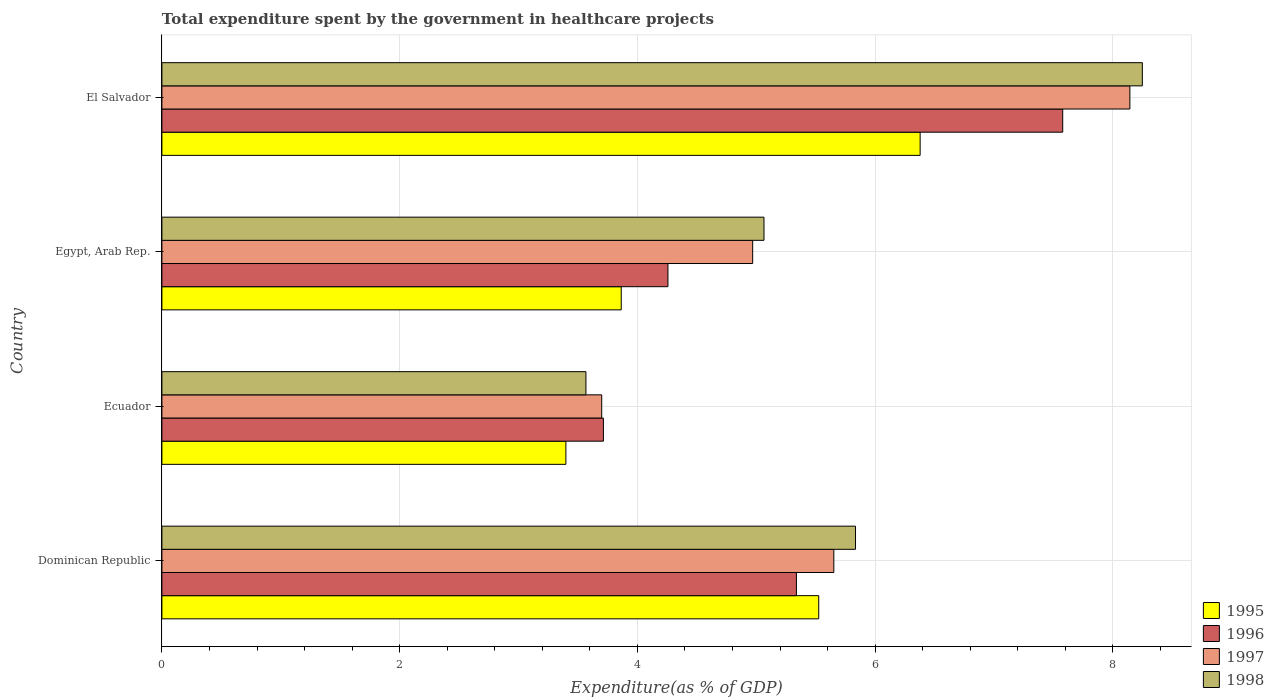How many different coloured bars are there?
Provide a succinct answer. 4. How many groups of bars are there?
Give a very brief answer. 4. Are the number of bars per tick equal to the number of legend labels?
Your answer should be compact. Yes. Are the number of bars on each tick of the Y-axis equal?
Give a very brief answer. Yes. How many bars are there on the 4th tick from the bottom?
Provide a succinct answer. 4. What is the label of the 3rd group of bars from the top?
Offer a very short reply. Ecuador. What is the total expenditure spent by the government in healthcare projects in 1996 in Egypt, Arab Rep.?
Offer a terse response. 4.26. Across all countries, what is the maximum total expenditure spent by the government in healthcare projects in 1995?
Your response must be concise. 6.38. Across all countries, what is the minimum total expenditure spent by the government in healthcare projects in 1997?
Ensure brevity in your answer.  3.7. In which country was the total expenditure spent by the government in healthcare projects in 1996 maximum?
Give a very brief answer. El Salvador. In which country was the total expenditure spent by the government in healthcare projects in 1997 minimum?
Offer a very short reply. Ecuador. What is the total total expenditure spent by the government in healthcare projects in 1997 in the graph?
Your answer should be very brief. 22.47. What is the difference between the total expenditure spent by the government in healthcare projects in 1995 in Dominican Republic and that in Egypt, Arab Rep.?
Provide a short and direct response. 1.66. What is the difference between the total expenditure spent by the government in healthcare projects in 1998 in Egypt, Arab Rep. and the total expenditure spent by the government in healthcare projects in 1996 in Ecuador?
Keep it short and to the point. 1.35. What is the average total expenditure spent by the government in healthcare projects in 1996 per country?
Ensure brevity in your answer.  5.22. What is the difference between the total expenditure spent by the government in healthcare projects in 1995 and total expenditure spent by the government in healthcare projects in 1996 in Ecuador?
Ensure brevity in your answer.  -0.32. In how many countries, is the total expenditure spent by the government in healthcare projects in 1997 greater than 7.2 %?
Provide a succinct answer. 1. What is the ratio of the total expenditure spent by the government in healthcare projects in 1995 in Egypt, Arab Rep. to that in El Salvador?
Provide a short and direct response. 0.61. Is the total expenditure spent by the government in healthcare projects in 1998 in Ecuador less than that in El Salvador?
Keep it short and to the point. Yes. Is the difference between the total expenditure spent by the government in healthcare projects in 1995 in Dominican Republic and El Salvador greater than the difference between the total expenditure spent by the government in healthcare projects in 1996 in Dominican Republic and El Salvador?
Make the answer very short. Yes. What is the difference between the highest and the second highest total expenditure spent by the government in healthcare projects in 1998?
Give a very brief answer. 2.41. What is the difference between the highest and the lowest total expenditure spent by the government in healthcare projects in 1996?
Your answer should be compact. 3.86. In how many countries, is the total expenditure spent by the government in healthcare projects in 1995 greater than the average total expenditure spent by the government in healthcare projects in 1995 taken over all countries?
Keep it short and to the point. 2. Is the sum of the total expenditure spent by the government in healthcare projects in 1997 in Egypt, Arab Rep. and El Salvador greater than the maximum total expenditure spent by the government in healthcare projects in 1995 across all countries?
Offer a terse response. Yes. What does the 2nd bar from the top in Egypt, Arab Rep. represents?
Provide a succinct answer. 1997. What does the 2nd bar from the bottom in Egypt, Arab Rep. represents?
Ensure brevity in your answer.  1996. Is it the case that in every country, the sum of the total expenditure spent by the government in healthcare projects in 1997 and total expenditure spent by the government in healthcare projects in 1998 is greater than the total expenditure spent by the government in healthcare projects in 1996?
Offer a terse response. Yes. How many bars are there?
Ensure brevity in your answer.  16. Are all the bars in the graph horizontal?
Ensure brevity in your answer.  Yes. How many countries are there in the graph?
Offer a very short reply. 4. Where does the legend appear in the graph?
Provide a short and direct response. Bottom right. What is the title of the graph?
Make the answer very short. Total expenditure spent by the government in healthcare projects. Does "2000" appear as one of the legend labels in the graph?
Offer a terse response. No. What is the label or title of the X-axis?
Your answer should be compact. Expenditure(as % of GDP). What is the label or title of the Y-axis?
Ensure brevity in your answer.  Country. What is the Expenditure(as % of GDP) in 1995 in Dominican Republic?
Keep it short and to the point. 5.53. What is the Expenditure(as % of GDP) in 1996 in Dominican Republic?
Provide a succinct answer. 5.34. What is the Expenditure(as % of GDP) in 1997 in Dominican Republic?
Make the answer very short. 5.65. What is the Expenditure(as % of GDP) in 1998 in Dominican Republic?
Your answer should be compact. 5.84. What is the Expenditure(as % of GDP) in 1995 in Ecuador?
Offer a terse response. 3.4. What is the Expenditure(as % of GDP) of 1996 in Ecuador?
Give a very brief answer. 3.71. What is the Expenditure(as % of GDP) of 1997 in Ecuador?
Offer a terse response. 3.7. What is the Expenditure(as % of GDP) in 1998 in Ecuador?
Provide a short and direct response. 3.57. What is the Expenditure(as % of GDP) of 1995 in Egypt, Arab Rep.?
Provide a succinct answer. 3.86. What is the Expenditure(as % of GDP) of 1996 in Egypt, Arab Rep.?
Give a very brief answer. 4.26. What is the Expenditure(as % of GDP) of 1997 in Egypt, Arab Rep.?
Ensure brevity in your answer.  4.97. What is the Expenditure(as % of GDP) of 1998 in Egypt, Arab Rep.?
Provide a succinct answer. 5.07. What is the Expenditure(as % of GDP) of 1995 in El Salvador?
Provide a short and direct response. 6.38. What is the Expenditure(as % of GDP) of 1996 in El Salvador?
Provide a succinct answer. 7.58. What is the Expenditure(as % of GDP) of 1997 in El Salvador?
Provide a succinct answer. 8.14. What is the Expenditure(as % of GDP) of 1998 in El Salvador?
Offer a terse response. 8.25. Across all countries, what is the maximum Expenditure(as % of GDP) of 1995?
Provide a succinct answer. 6.38. Across all countries, what is the maximum Expenditure(as % of GDP) of 1996?
Provide a short and direct response. 7.58. Across all countries, what is the maximum Expenditure(as % of GDP) in 1997?
Provide a short and direct response. 8.14. Across all countries, what is the maximum Expenditure(as % of GDP) in 1998?
Your answer should be compact. 8.25. Across all countries, what is the minimum Expenditure(as % of GDP) of 1995?
Keep it short and to the point. 3.4. Across all countries, what is the minimum Expenditure(as % of GDP) in 1996?
Offer a very short reply. 3.71. Across all countries, what is the minimum Expenditure(as % of GDP) of 1997?
Your answer should be compact. 3.7. Across all countries, what is the minimum Expenditure(as % of GDP) of 1998?
Ensure brevity in your answer.  3.57. What is the total Expenditure(as % of GDP) in 1995 in the graph?
Offer a very short reply. 19.17. What is the total Expenditure(as % of GDP) of 1996 in the graph?
Give a very brief answer. 20.89. What is the total Expenditure(as % of GDP) of 1997 in the graph?
Give a very brief answer. 22.47. What is the total Expenditure(as % of GDP) of 1998 in the graph?
Your answer should be compact. 22.72. What is the difference between the Expenditure(as % of GDP) of 1995 in Dominican Republic and that in Ecuador?
Your answer should be very brief. 2.13. What is the difference between the Expenditure(as % of GDP) of 1996 in Dominican Republic and that in Ecuador?
Your response must be concise. 1.62. What is the difference between the Expenditure(as % of GDP) in 1997 in Dominican Republic and that in Ecuador?
Provide a short and direct response. 1.95. What is the difference between the Expenditure(as % of GDP) in 1998 in Dominican Republic and that in Ecuador?
Offer a terse response. 2.27. What is the difference between the Expenditure(as % of GDP) of 1995 in Dominican Republic and that in Egypt, Arab Rep.?
Your answer should be very brief. 1.66. What is the difference between the Expenditure(as % of GDP) in 1996 in Dominican Republic and that in Egypt, Arab Rep.?
Provide a succinct answer. 1.08. What is the difference between the Expenditure(as % of GDP) of 1997 in Dominican Republic and that in Egypt, Arab Rep.?
Your answer should be very brief. 0.68. What is the difference between the Expenditure(as % of GDP) in 1998 in Dominican Republic and that in Egypt, Arab Rep.?
Give a very brief answer. 0.77. What is the difference between the Expenditure(as % of GDP) in 1995 in Dominican Republic and that in El Salvador?
Give a very brief answer. -0.85. What is the difference between the Expenditure(as % of GDP) of 1996 in Dominican Republic and that in El Salvador?
Your answer should be very brief. -2.24. What is the difference between the Expenditure(as % of GDP) in 1997 in Dominican Republic and that in El Salvador?
Make the answer very short. -2.49. What is the difference between the Expenditure(as % of GDP) of 1998 in Dominican Republic and that in El Salvador?
Keep it short and to the point. -2.41. What is the difference between the Expenditure(as % of GDP) of 1995 in Ecuador and that in Egypt, Arab Rep.?
Give a very brief answer. -0.47. What is the difference between the Expenditure(as % of GDP) of 1996 in Ecuador and that in Egypt, Arab Rep.?
Offer a terse response. -0.54. What is the difference between the Expenditure(as % of GDP) of 1997 in Ecuador and that in Egypt, Arab Rep.?
Ensure brevity in your answer.  -1.27. What is the difference between the Expenditure(as % of GDP) of 1998 in Ecuador and that in Egypt, Arab Rep.?
Your response must be concise. -1.5. What is the difference between the Expenditure(as % of GDP) in 1995 in Ecuador and that in El Salvador?
Provide a short and direct response. -2.98. What is the difference between the Expenditure(as % of GDP) of 1996 in Ecuador and that in El Salvador?
Your answer should be compact. -3.86. What is the difference between the Expenditure(as % of GDP) of 1997 in Ecuador and that in El Salvador?
Your answer should be compact. -4.44. What is the difference between the Expenditure(as % of GDP) of 1998 in Ecuador and that in El Salvador?
Keep it short and to the point. -4.68. What is the difference between the Expenditure(as % of GDP) of 1995 in Egypt, Arab Rep. and that in El Salvador?
Keep it short and to the point. -2.51. What is the difference between the Expenditure(as % of GDP) in 1996 in Egypt, Arab Rep. and that in El Salvador?
Ensure brevity in your answer.  -3.32. What is the difference between the Expenditure(as % of GDP) of 1997 in Egypt, Arab Rep. and that in El Salvador?
Provide a succinct answer. -3.17. What is the difference between the Expenditure(as % of GDP) of 1998 in Egypt, Arab Rep. and that in El Salvador?
Keep it short and to the point. -3.18. What is the difference between the Expenditure(as % of GDP) in 1995 in Dominican Republic and the Expenditure(as % of GDP) in 1996 in Ecuador?
Your answer should be very brief. 1.81. What is the difference between the Expenditure(as % of GDP) in 1995 in Dominican Republic and the Expenditure(as % of GDP) in 1997 in Ecuador?
Ensure brevity in your answer.  1.83. What is the difference between the Expenditure(as % of GDP) in 1995 in Dominican Republic and the Expenditure(as % of GDP) in 1998 in Ecuador?
Your answer should be compact. 1.96. What is the difference between the Expenditure(as % of GDP) in 1996 in Dominican Republic and the Expenditure(as % of GDP) in 1997 in Ecuador?
Your answer should be very brief. 1.64. What is the difference between the Expenditure(as % of GDP) of 1996 in Dominican Republic and the Expenditure(as % of GDP) of 1998 in Ecuador?
Make the answer very short. 1.77. What is the difference between the Expenditure(as % of GDP) of 1997 in Dominican Republic and the Expenditure(as % of GDP) of 1998 in Ecuador?
Your answer should be very brief. 2.09. What is the difference between the Expenditure(as % of GDP) of 1995 in Dominican Republic and the Expenditure(as % of GDP) of 1996 in Egypt, Arab Rep.?
Your answer should be very brief. 1.27. What is the difference between the Expenditure(as % of GDP) of 1995 in Dominican Republic and the Expenditure(as % of GDP) of 1997 in Egypt, Arab Rep.?
Your response must be concise. 0.56. What is the difference between the Expenditure(as % of GDP) of 1995 in Dominican Republic and the Expenditure(as % of GDP) of 1998 in Egypt, Arab Rep.?
Provide a succinct answer. 0.46. What is the difference between the Expenditure(as % of GDP) in 1996 in Dominican Republic and the Expenditure(as % of GDP) in 1997 in Egypt, Arab Rep.?
Your answer should be very brief. 0.37. What is the difference between the Expenditure(as % of GDP) of 1996 in Dominican Republic and the Expenditure(as % of GDP) of 1998 in Egypt, Arab Rep.?
Ensure brevity in your answer.  0.27. What is the difference between the Expenditure(as % of GDP) of 1997 in Dominican Republic and the Expenditure(as % of GDP) of 1998 in Egypt, Arab Rep.?
Your response must be concise. 0.59. What is the difference between the Expenditure(as % of GDP) in 1995 in Dominican Republic and the Expenditure(as % of GDP) in 1996 in El Salvador?
Make the answer very short. -2.05. What is the difference between the Expenditure(as % of GDP) in 1995 in Dominican Republic and the Expenditure(as % of GDP) in 1997 in El Salvador?
Give a very brief answer. -2.62. What is the difference between the Expenditure(as % of GDP) of 1995 in Dominican Republic and the Expenditure(as % of GDP) of 1998 in El Salvador?
Your response must be concise. -2.72. What is the difference between the Expenditure(as % of GDP) in 1996 in Dominican Republic and the Expenditure(as % of GDP) in 1997 in El Salvador?
Make the answer very short. -2.81. What is the difference between the Expenditure(as % of GDP) of 1996 in Dominican Republic and the Expenditure(as % of GDP) of 1998 in El Salvador?
Offer a very short reply. -2.91. What is the difference between the Expenditure(as % of GDP) in 1997 in Dominican Republic and the Expenditure(as % of GDP) in 1998 in El Salvador?
Ensure brevity in your answer.  -2.6. What is the difference between the Expenditure(as % of GDP) in 1995 in Ecuador and the Expenditure(as % of GDP) in 1996 in Egypt, Arab Rep.?
Your response must be concise. -0.86. What is the difference between the Expenditure(as % of GDP) in 1995 in Ecuador and the Expenditure(as % of GDP) in 1997 in Egypt, Arab Rep.?
Make the answer very short. -1.57. What is the difference between the Expenditure(as % of GDP) of 1995 in Ecuador and the Expenditure(as % of GDP) of 1998 in Egypt, Arab Rep.?
Ensure brevity in your answer.  -1.67. What is the difference between the Expenditure(as % of GDP) in 1996 in Ecuador and the Expenditure(as % of GDP) in 1997 in Egypt, Arab Rep.?
Offer a very short reply. -1.26. What is the difference between the Expenditure(as % of GDP) of 1996 in Ecuador and the Expenditure(as % of GDP) of 1998 in Egypt, Arab Rep.?
Ensure brevity in your answer.  -1.35. What is the difference between the Expenditure(as % of GDP) in 1997 in Ecuador and the Expenditure(as % of GDP) in 1998 in Egypt, Arab Rep.?
Make the answer very short. -1.37. What is the difference between the Expenditure(as % of GDP) of 1995 in Ecuador and the Expenditure(as % of GDP) of 1996 in El Salvador?
Provide a succinct answer. -4.18. What is the difference between the Expenditure(as % of GDP) in 1995 in Ecuador and the Expenditure(as % of GDP) in 1997 in El Salvador?
Provide a succinct answer. -4.74. What is the difference between the Expenditure(as % of GDP) of 1995 in Ecuador and the Expenditure(as % of GDP) of 1998 in El Salvador?
Your response must be concise. -4.85. What is the difference between the Expenditure(as % of GDP) in 1996 in Ecuador and the Expenditure(as % of GDP) in 1997 in El Salvador?
Your answer should be compact. -4.43. What is the difference between the Expenditure(as % of GDP) in 1996 in Ecuador and the Expenditure(as % of GDP) in 1998 in El Salvador?
Offer a terse response. -4.53. What is the difference between the Expenditure(as % of GDP) of 1997 in Ecuador and the Expenditure(as % of GDP) of 1998 in El Salvador?
Keep it short and to the point. -4.55. What is the difference between the Expenditure(as % of GDP) of 1995 in Egypt, Arab Rep. and the Expenditure(as % of GDP) of 1996 in El Salvador?
Your answer should be compact. -3.71. What is the difference between the Expenditure(as % of GDP) in 1995 in Egypt, Arab Rep. and the Expenditure(as % of GDP) in 1997 in El Salvador?
Give a very brief answer. -4.28. What is the difference between the Expenditure(as % of GDP) in 1995 in Egypt, Arab Rep. and the Expenditure(as % of GDP) in 1998 in El Salvador?
Your answer should be very brief. -4.38. What is the difference between the Expenditure(as % of GDP) of 1996 in Egypt, Arab Rep. and the Expenditure(as % of GDP) of 1997 in El Salvador?
Ensure brevity in your answer.  -3.89. What is the difference between the Expenditure(as % of GDP) in 1996 in Egypt, Arab Rep. and the Expenditure(as % of GDP) in 1998 in El Salvador?
Your response must be concise. -3.99. What is the difference between the Expenditure(as % of GDP) in 1997 in Egypt, Arab Rep. and the Expenditure(as % of GDP) in 1998 in El Salvador?
Give a very brief answer. -3.28. What is the average Expenditure(as % of GDP) in 1995 per country?
Provide a short and direct response. 4.79. What is the average Expenditure(as % of GDP) of 1996 per country?
Make the answer very short. 5.22. What is the average Expenditure(as % of GDP) of 1997 per country?
Offer a very short reply. 5.62. What is the average Expenditure(as % of GDP) in 1998 per country?
Make the answer very short. 5.68. What is the difference between the Expenditure(as % of GDP) in 1995 and Expenditure(as % of GDP) in 1996 in Dominican Republic?
Your response must be concise. 0.19. What is the difference between the Expenditure(as % of GDP) in 1995 and Expenditure(as % of GDP) in 1997 in Dominican Republic?
Provide a short and direct response. -0.13. What is the difference between the Expenditure(as % of GDP) of 1995 and Expenditure(as % of GDP) of 1998 in Dominican Republic?
Provide a succinct answer. -0.31. What is the difference between the Expenditure(as % of GDP) in 1996 and Expenditure(as % of GDP) in 1997 in Dominican Republic?
Ensure brevity in your answer.  -0.31. What is the difference between the Expenditure(as % of GDP) of 1996 and Expenditure(as % of GDP) of 1998 in Dominican Republic?
Your answer should be compact. -0.5. What is the difference between the Expenditure(as % of GDP) of 1997 and Expenditure(as % of GDP) of 1998 in Dominican Republic?
Ensure brevity in your answer.  -0.18. What is the difference between the Expenditure(as % of GDP) of 1995 and Expenditure(as % of GDP) of 1996 in Ecuador?
Give a very brief answer. -0.32. What is the difference between the Expenditure(as % of GDP) of 1995 and Expenditure(as % of GDP) of 1997 in Ecuador?
Make the answer very short. -0.3. What is the difference between the Expenditure(as % of GDP) in 1995 and Expenditure(as % of GDP) in 1998 in Ecuador?
Give a very brief answer. -0.17. What is the difference between the Expenditure(as % of GDP) in 1996 and Expenditure(as % of GDP) in 1997 in Ecuador?
Ensure brevity in your answer.  0.01. What is the difference between the Expenditure(as % of GDP) in 1996 and Expenditure(as % of GDP) in 1998 in Ecuador?
Provide a succinct answer. 0.15. What is the difference between the Expenditure(as % of GDP) of 1997 and Expenditure(as % of GDP) of 1998 in Ecuador?
Your response must be concise. 0.13. What is the difference between the Expenditure(as % of GDP) in 1995 and Expenditure(as % of GDP) in 1996 in Egypt, Arab Rep.?
Keep it short and to the point. -0.39. What is the difference between the Expenditure(as % of GDP) of 1995 and Expenditure(as % of GDP) of 1997 in Egypt, Arab Rep.?
Your answer should be compact. -1.11. What is the difference between the Expenditure(as % of GDP) in 1995 and Expenditure(as % of GDP) in 1998 in Egypt, Arab Rep.?
Provide a succinct answer. -1.2. What is the difference between the Expenditure(as % of GDP) in 1996 and Expenditure(as % of GDP) in 1997 in Egypt, Arab Rep.?
Your answer should be compact. -0.71. What is the difference between the Expenditure(as % of GDP) of 1996 and Expenditure(as % of GDP) of 1998 in Egypt, Arab Rep.?
Your response must be concise. -0.81. What is the difference between the Expenditure(as % of GDP) in 1997 and Expenditure(as % of GDP) in 1998 in Egypt, Arab Rep.?
Provide a short and direct response. -0.1. What is the difference between the Expenditure(as % of GDP) of 1995 and Expenditure(as % of GDP) of 1996 in El Salvador?
Make the answer very short. -1.2. What is the difference between the Expenditure(as % of GDP) in 1995 and Expenditure(as % of GDP) in 1997 in El Salvador?
Ensure brevity in your answer.  -1.76. What is the difference between the Expenditure(as % of GDP) in 1995 and Expenditure(as % of GDP) in 1998 in El Salvador?
Offer a very short reply. -1.87. What is the difference between the Expenditure(as % of GDP) of 1996 and Expenditure(as % of GDP) of 1997 in El Salvador?
Give a very brief answer. -0.56. What is the difference between the Expenditure(as % of GDP) of 1996 and Expenditure(as % of GDP) of 1998 in El Salvador?
Your answer should be compact. -0.67. What is the difference between the Expenditure(as % of GDP) of 1997 and Expenditure(as % of GDP) of 1998 in El Salvador?
Offer a very short reply. -0.1. What is the ratio of the Expenditure(as % of GDP) of 1995 in Dominican Republic to that in Ecuador?
Make the answer very short. 1.63. What is the ratio of the Expenditure(as % of GDP) of 1996 in Dominican Republic to that in Ecuador?
Your answer should be very brief. 1.44. What is the ratio of the Expenditure(as % of GDP) in 1997 in Dominican Republic to that in Ecuador?
Your answer should be very brief. 1.53. What is the ratio of the Expenditure(as % of GDP) of 1998 in Dominican Republic to that in Ecuador?
Your answer should be very brief. 1.64. What is the ratio of the Expenditure(as % of GDP) of 1995 in Dominican Republic to that in Egypt, Arab Rep.?
Offer a terse response. 1.43. What is the ratio of the Expenditure(as % of GDP) of 1996 in Dominican Republic to that in Egypt, Arab Rep.?
Provide a short and direct response. 1.25. What is the ratio of the Expenditure(as % of GDP) in 1997 in Dominican Republic to that in Egypt, Arab Rep.?
Your answer should be compact. 1.14. What is the ratio of the Expenditure(as % of GDP) of 1998 in Dominican Republic to that in Egypt, Arab Rep.?
Ensure brevity in your answer.  1.15. What is the ratio of the Expenditure(as % of GDP) in 1995 in Dominican Republic to that in El Salvador?
Keep it short and to the point. 0.87. What is the ratio of the Expenditure(as % of GDP) of 1996 in Dominican Republic to that in El Salvador?
Your answer should be very brief. 0.7. What is the ratio of the Expenditure(as % of GDP) in 1997 in Dominican Republic to that in El Salvador?
Your answer should be very brief. 0.69. What is the ratio of the Expenditure(as % of GDP) of 1998 in Dominican Republic to that in El Salvador?
Offer a very short reply. 0.71. What is the ratio of the Expenditure(as % of GDP) of 1995 in Ecuador to that in Egypt, Arab Rep.?
Provide a short and direct response. 0.88. What is the ratio of the Expenditure(as % of GDP) in 1996 in Ecuador to that in Egypt, Arab Rep.?
Your answer should be very brief. 0.87. What is the ratio of the Expenditure(as % of GDP) in 1997 in Ecuador to that in Egypt, Arab Rep.?
Your response must be concise. 0.74. What is the ratio of the Expenditure(as % of GDP) in 1998 in Ecuador to that in Egypt, Arab Rep.?
Offer a very short reply. 0.7. What is the ratio of the Expenditure(as % of GDP) of 1995 in Ecuador to that in El Salvador?
Your answer should be compact. 0.53. What is the ratio of the Expenditure(as % of GDP) of 1996 in Ecuador to that in El Salvador?
Offer a very short reply. 0.49. What is the ratio of the Expenditure(as % of GDP) in 1997 in Ecuador to that in El Salvador?
Keep it short and to the point. 0.45. What is the ratio of the Expenditure(as % of GDP) in 1998 in Ecuador to that in El Salvador?
Ensure brevity in your answer.  0.43. What is the ratio of the Expenditure(as % of GDP) of 1995 in Egypt, Arab Rep. to that in El Salvador?
Give a very brief answer. 0.61. What is the ratio of the Expenditure(as % of GDP) in 1996 in Egypt, Arab Rep. to that in El Salvador?
Ensure brevity in your answer.  0.56. What is the ratio of the Expenditure(as % of GDP) of 1997 in Egypt, Arab Rep. to that in El Salvador?
Provide a succinct answer. 0.61. What is the ratio of the Expenditure(as % of GDP) of 1998 in Egypt, Arab Rep. to that in El Salvador?
Make the answer very short. 0.61. What is the difference between the highest and the second highest Expenditure(as % of GDP) of 1995?
Give a very brief answer. 0.85. What is the difference between the highest and the second highest Expenditure(as % of GDP) of 1996?
Keep it short and to the point. 2.24. What is the difference between the highest and the second highest Expenditure(as % of GDP) of 1997?
Ensure brevity in your answer.  2.49. What is the difference between the highest and the second highest Expenditure(as % of GDP) in 1998?
Provide a short and direct response. 2.41. What is the difference between the highest and the lowest Expenditure(as % of GDP) in 1995?
Keep it short and to the point. 2.98. What is the difference between the highest and the lowest Expenditure(as % of GDP) in 1996?
Provide a succinct answer. 3.86. What is the difference between the highest and the lowest Expenditure(as % of GDP) of 1997?
Ensure brevity in your answer.  4.44. What is the difference between the highest and the lowest Expenditure(as % of GDP) of 1998?
Offer a very short reply. 4.68. 